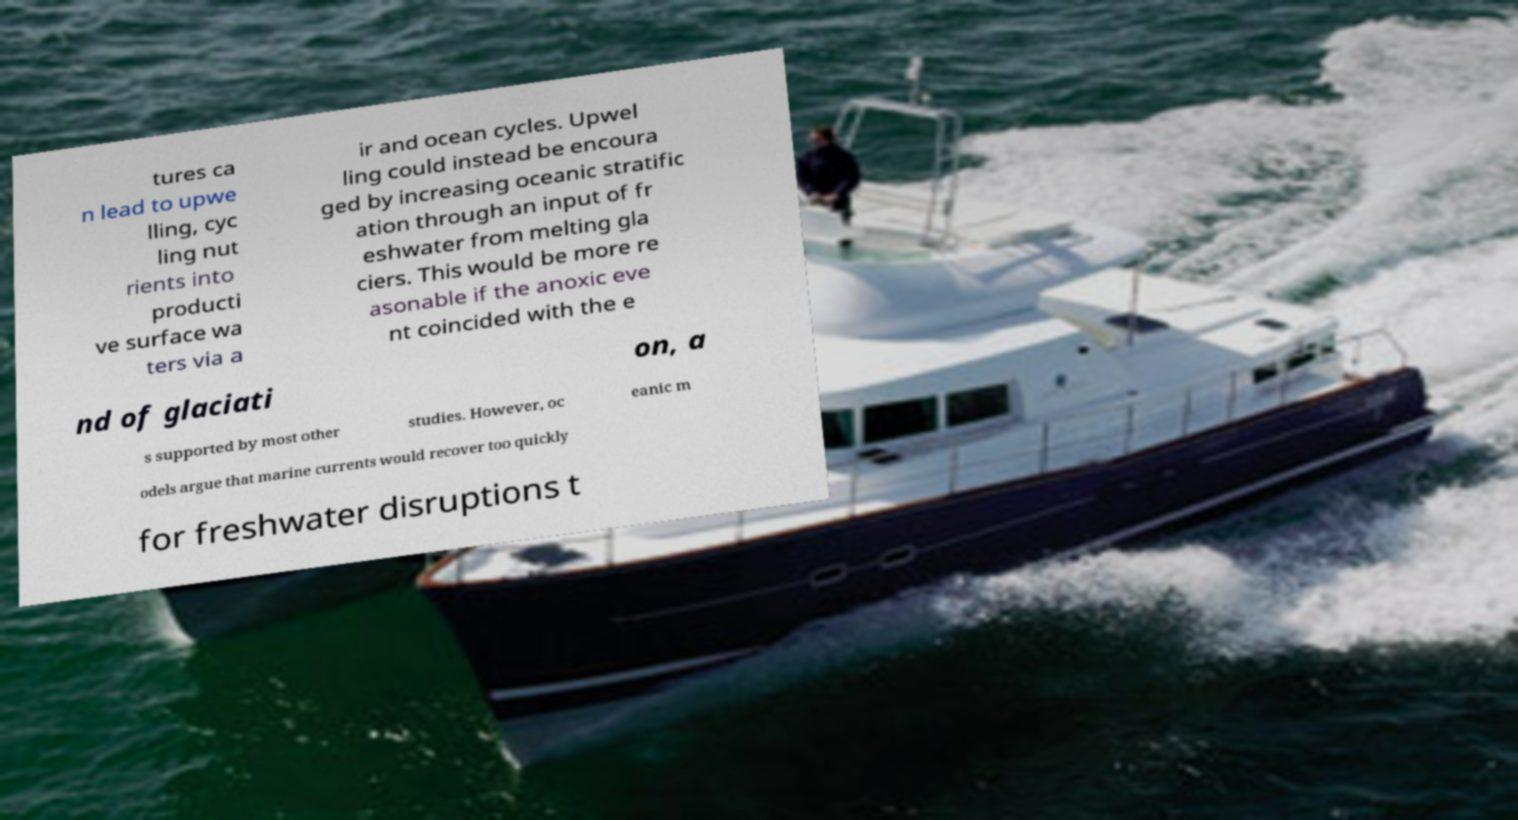Please read and relay the text visible in this image. What does it say? tures ca n lead to upwe lling, cyc ling nut rients into producti ve surface wa ters via a ir and ocean cycles. Upwel ling could instead be encoura ged by increasing oceanic stratific ation through an input of fr eshwater from melting gla ciers. This would be more re asonable if the anoxic eve nt coincided with the e nd of glaciati on, a s supported by most other studies. However, oc eanic m odels argue that marine currents would recover too quickly for freshwater disruptions t 